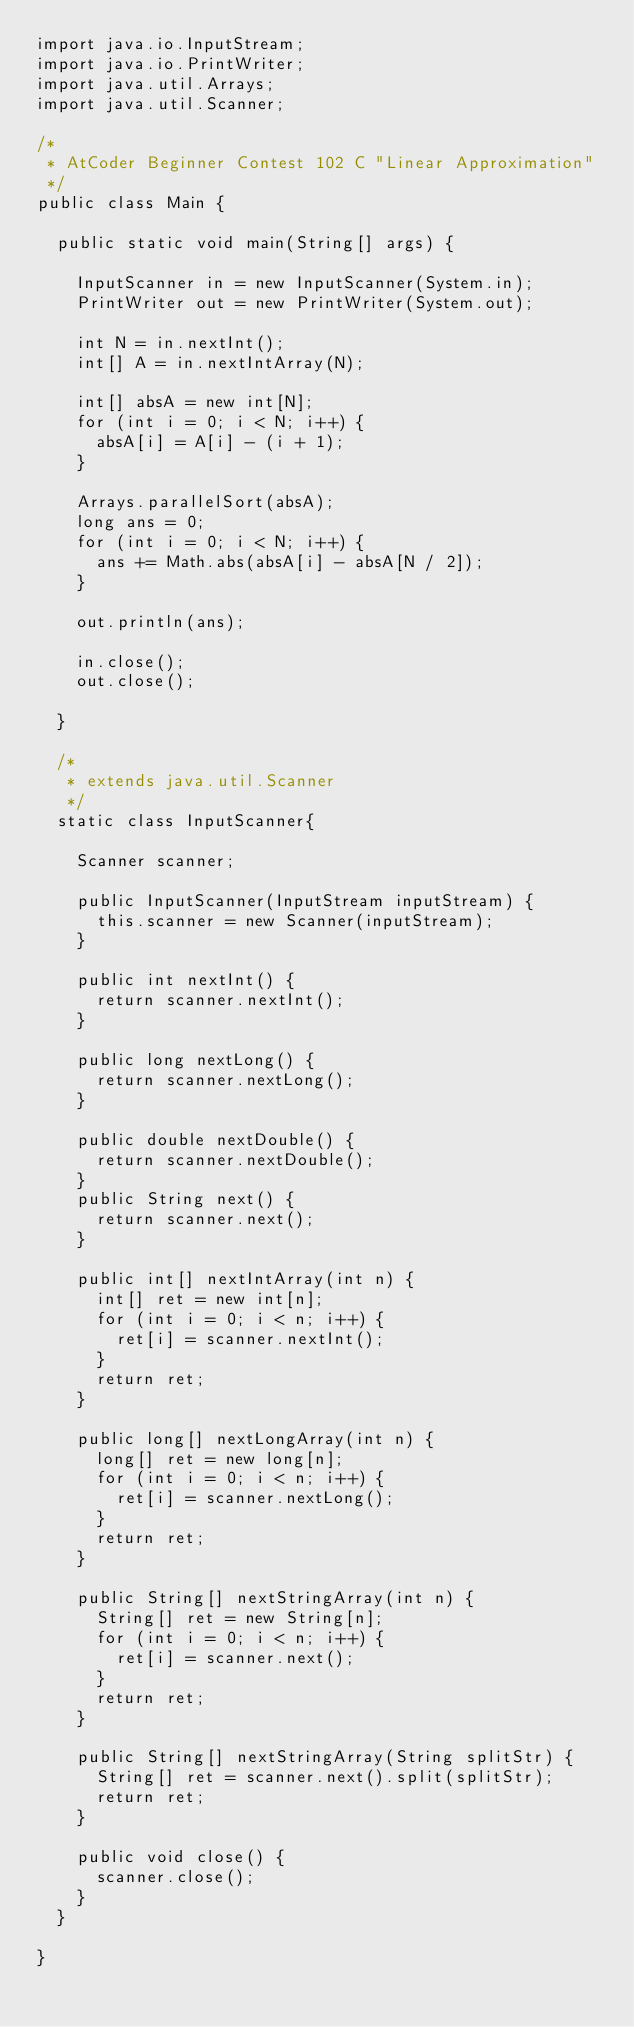Convert code to text. <code><loc_0><loc_0><loc_500><loc_500><_Java_>import java.io.InputStream;
import java.io.PrintWriter;
import java.util.Arrays;
import java.util.Scanner;

/*
 * AtCoder Beginner Contest 102 C "Linear Approximation"
 */
public class Main {

	public static void main(String[] args) {

		InputScanner in = new InputScanner(System.in);
		PrintWriter out = new PrintWriter(System.out);

		int N = in.nextInt();
		int[] A = in.nextIntArray(N);

		int[] absA = new int[N];
		for (int i = 0; i < N; i++) {
			absA[i] = A[i] - (i + 1);
		}

		Arrays.parallelSort(absA);
		long ans = 0;
		for (int i = 0; i < N; i++) {
			ans += Math.abs(absA[i] - absA[N / 2]);
		}

		out.println(ans);

		in.close();
		out.close();

	}

	/*
	 * extends java.util.Scanner
	 */
	static class InputScanner{

		Scanner scanner;

		public InputScanner(InputStream inputStream) {
			this.scanner = new Scanner(inputStream);
		}

		public int nextInt() {
			return scanner.nextInt();
		}

		public long nextLong() {
			return scanner.nextLong();
		}

		public double nextDouble() {
			return scanner.nextDouble();
		}
		public String next() {
			return scanner.next();
		}

		public int[] nextIntArray(int n) {
			int[] ret = new int[n];
			for (int i = 0; i < n; i++) {
				ret[i] = scanner.nextInt();
			}
			return ret;
		}

		public long[] nextLongArray(int n) {
			long[] ret = new long[n];
			for (int i = 0; i < n; i++) {
				ret[i] = scanner.nextLong();
			}
			return ret;
		}

		public String[] nextStringArray(int n) {
			String[] ret = new String[n];
			for (int i = 0; i < n; i++) {
				ret[i] = scanner.next();
			}
			return ret;
		}

		public String[] nextStringArray(String splitStr) {
			String[] ret = scanner.next().split(splitStr);
			return ret;
		}

		public void close() {
			scanner.close();
		}
	}

}
</code> 